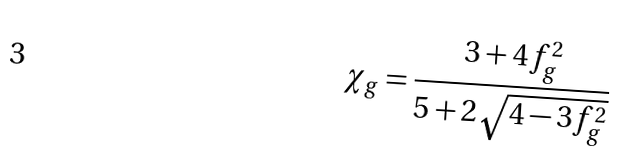<formula> <loc_0><loc_0><loc_500><loc_500>\chi _ { g } = \frac { 3 + 4 f _ { g } ^ { 2 } } { 5 + 2 \sqrt { 4 - 3 f _ { g } ^ { 2 } } }</formula> 